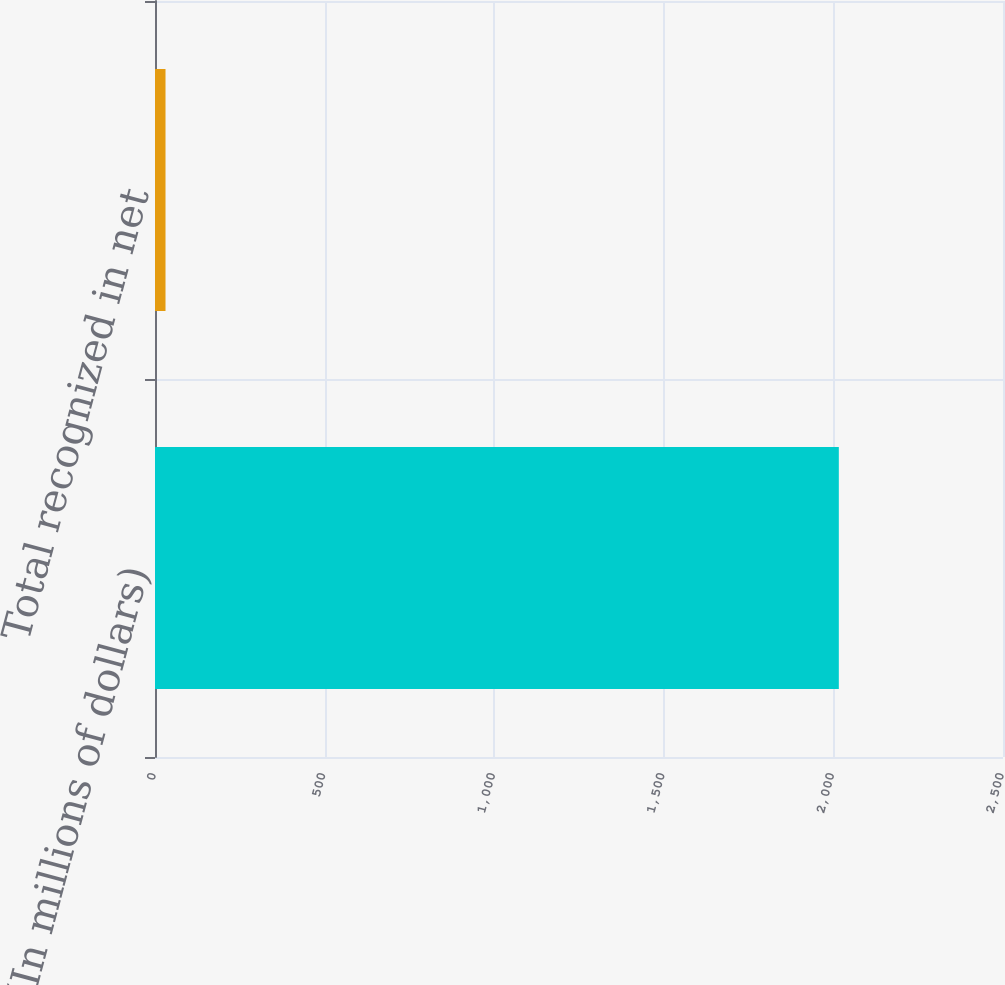Convert chart to OTSL. <chart><loc_0><loc_0><loc_500><loc_500><bar_chart><fcel>(In millions of dollars)<fcel>Total recognized in net<nl><fcel>2016<fcel>31<nl></chart> 